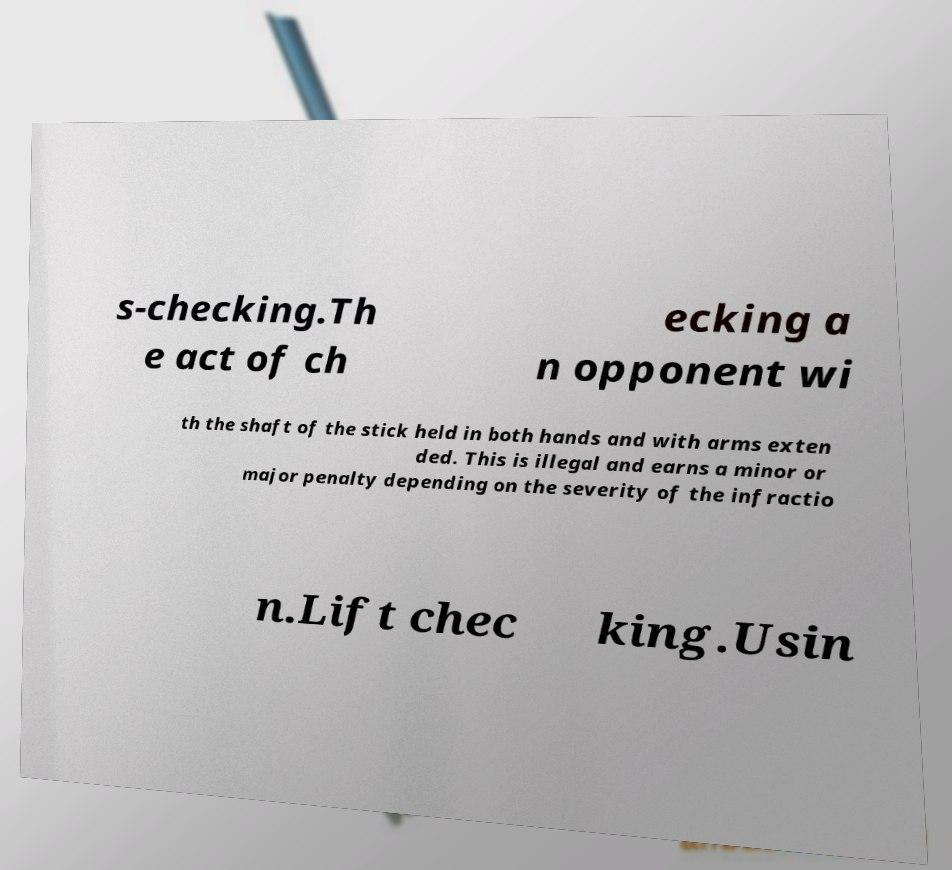What messages or text are displayed in this image? I need them in a readable, typed format. s-checking.Th e act of ch ecking a n opponent wi th the shaft of the stick held in both hands and with arms exten ded. This is illegal and earns a minor or major penalty depending on the severity of the infractio n.Lift chec king.Usin 